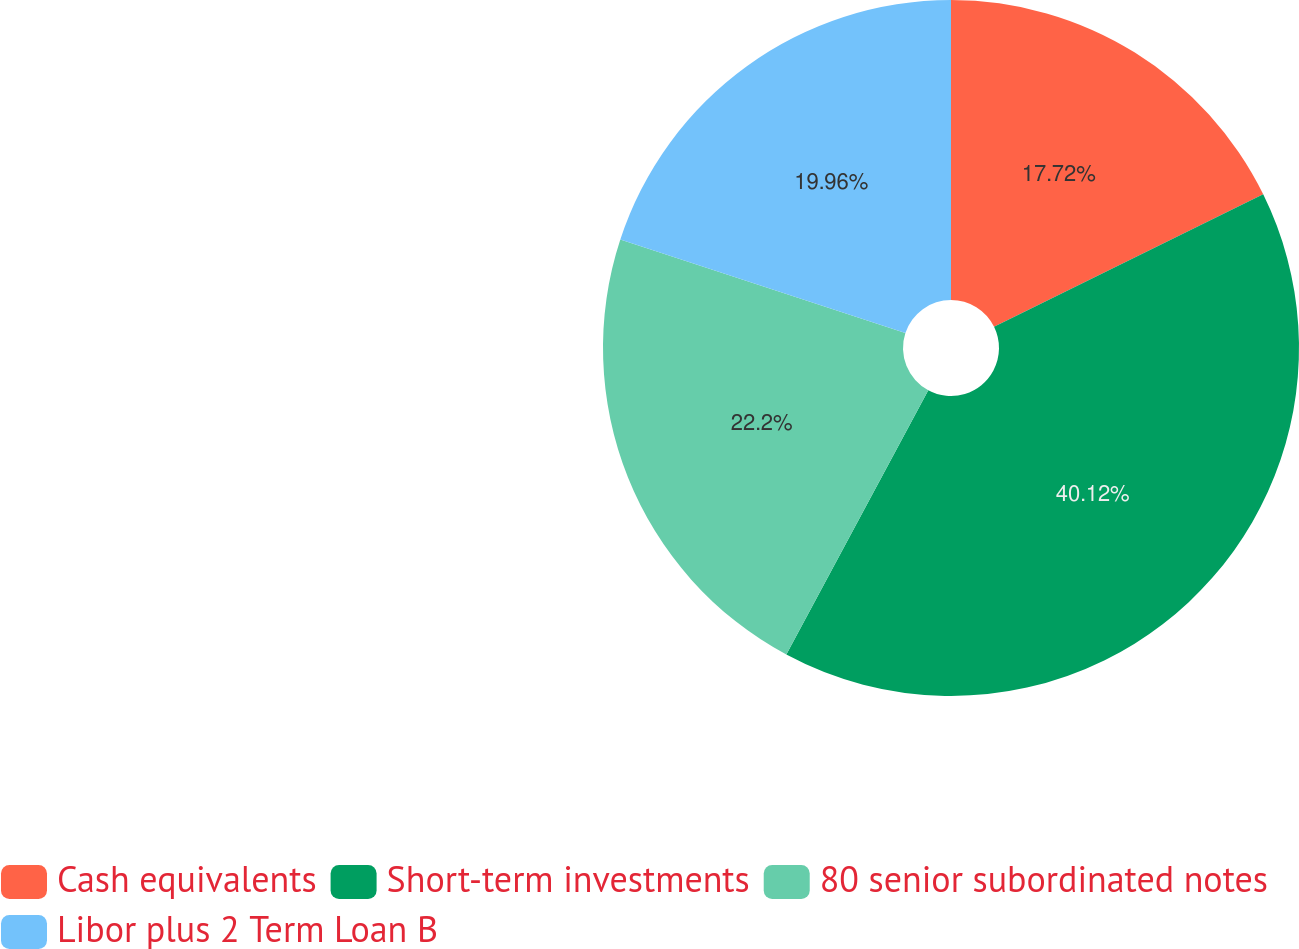Convert chart. <chart><loc_0><loc_0><loc_500><loc_500><pie_chart><fcel>Cash equivalents<fcel>Short-term investments<fcel>80 senior subordinated notes<fcel>Libor plus 2 Term Loan B<nl><fcel>17.72%<fcel>40.13%<fcel>22.2%<fcel>19.96%<nl></chart> 